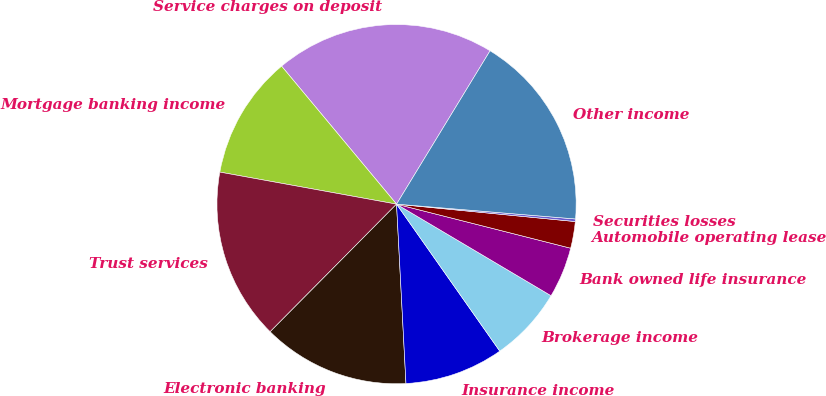Convert chart to OTSL. <chart><loc_0><loc_0><loc_500><loc_500><pie_chart><fcel>Service charges on deposit<fcel>Mortgage banking income<fcel>Trust services<fcel>Electronic banking<fcel>Insurance income<fcel>Brokerage income<fcel>Bank owned life insurance<fcel>Automobile operating lease<fcel>Securities losses<fcel>Other income<nl><fcel>19.77%<fcel>11.09%<fcel>15.43%<fcel>13.26%<fcel>8.91%<fcel>6.74%<fcel>4.57%<fcel>2.4%<fcel>0.23%<fcel>17.6%<nl></chart> 